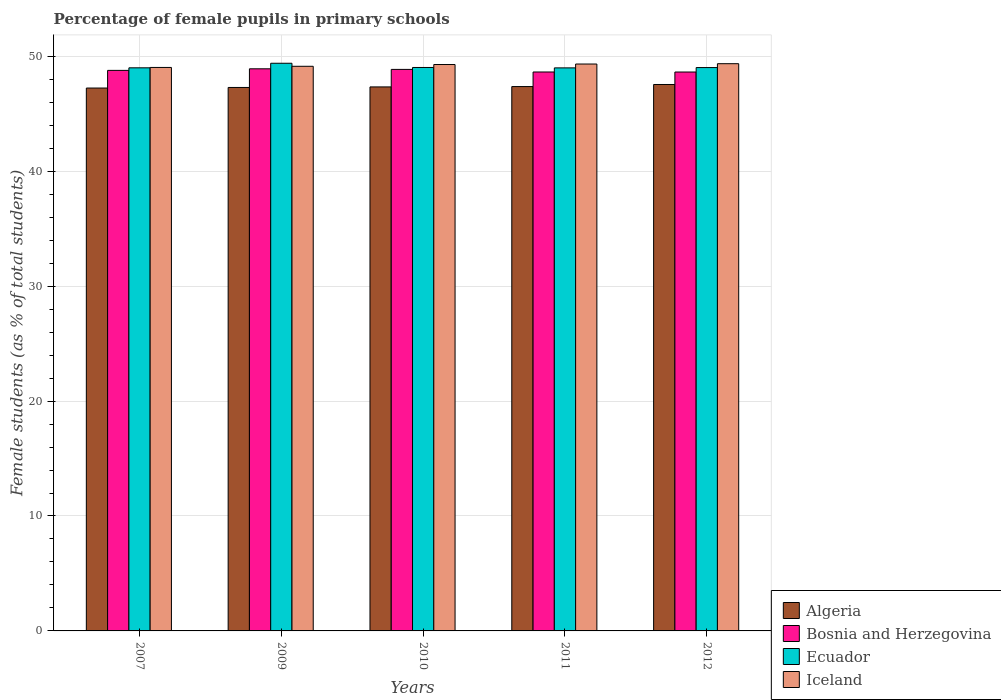How many groups of bars are there?
Ensure brevity in your answer.  5. Are the number of bars per tick equal to the number of legend labels?
Your answer should be compact. Yes. What is the percentage of female pupils in primary schools in Algeria in 2010?
Your response must be concise. 47.34. Across all years, what is the maximum percentage of female pupils in primary schools in Bosnia and Herzegovina?
Your response must be concise. 48.91. Across all years, what is the minimum percentage of female pupils in primary schools in Ecuador?
Offer a terse response. 48.99. What is the total percentage of female pupils in primary schools in Ecuador in the graph?
Provide a short and direct response. 245.42. What is the difference between the percentage of female pupils in primary schools in Iceland in 2007 and that in 2012?
Your response must be concise. -0.33. What is the difference between the percentage of female pupils in primary schools in Ecuador in 2010 and the percentage of female pupils in primary schools in Algeria in 2009?
Provide a succinct answer. 1.74. What is the average percentage of female pupils in primary schools in Ecuador per year?
Offer a very short reply. 49.08. In the year 2010, what is the difference between the percentage of female pupils in primary schools in Iceland and percentage of female pupils in primary schools in Bosnia and Herzegovina?
Provide a short and direct response. 0.42. What is the ratio of the percentage of female pupils in primary schools in Ecuador in 2009 to that in 2012?
Your response must be concise. 1.01. What is the difference between the highest and the second highest percentage of female pupils in primary schools in Ecuador?
Give a very brief answer. 0.37. What is the difference between the highest and the lowest percentage of female pupils in primary schools in Iceland?
Make the answer very short. 0.33. In how many years, is the percentage of female pupils in primary schools in Ecuador greater than the average percentage of female pupils in primary schools in Ecuador taken over all years?
Offer a very short reply. 1. Is it the case that in every year, the sum of the percentage of female pupils in primary schools in Algeria and percentage of female pupils in primary schools in Iceland is greater than the sum of percentage of female pupils in primary schools in Ecuador and percentage of female pupils in primary schools in Bosnia and Herzegovina?
Offer a very short reply. No. What does the 3rd bar from the left in 2007 represents?
Your answer should be compact. Ecuador. What does the 4th bar from the right in 2010 represents?
Ensure brevity in your answer.  Algeria. Is it the case that in every year, the sum of the percentage of female pupils in primary schools in Iceland and percentage of female pupils in primary schools in Ecuador is greater than the percentage of female pupils in primary schools in Bosnia and Herzegovina?
Make the answer very short. Yes. Are all the bars in the graph horizontal?
Your response must be concise. No. How many years are there in the graph?
Make the answer very short. 5. What is the difference between two consecutive major ticks on the Y-axis?
Your answer should be compact. 10. Does the graph contain any zero values?
Your response must be concise. No. Does the graph contain grids?
Provide a succinct answer. Yes. Where does the legend appear in the graph?
Your answer should be compact. Bottom right. How many legend labels are there?
Ensure brevity in your answer.  4. How are the legend labels stacked?
Offer a very short reply. Vertical. What is the title of the graph?
Your answer should be very brief. Percentage of female pupils in primary schools. Does "United Arab Emirates" appear as one of the legend labels in the graph?
Your response must be concise. No. What is the label or title of the X-axis?
Provide a short and direct response. Years. What is the label or title of the Y-axis?
Your answer should be compact. Female students (as % of total students). What is the Female students (as % of total students) in Algeria in 2007?
Offer a very short reply. 47.24. What is the Female students (as % of total students) in Bosnia and Herzegovina in 2007?
Provide a succinct answer. 48.77. What is the Female students (as % of total students) in Ecuador in 2007?
Provide a succinct answer. 49. What is the Female students (as % of total students) of Iceland in 2007?
Offer a very short reply. 49.03. What is the Female students (as % of total students) of Algeria in 2009?
Offer a very short reply. 47.29. What is the Female students (as % of total students) of Bosnia and Herzegovina in 2009?
Provide a short and direct response. 48.91. What is the Female students (as % of total students) of Ecuador in 2009?
Make the answer very short. 49.39. What is the Female students (as % of total students) in Iceland in 2009?
Provide a succinct answer. 49.13. What is the Female students (as % of total students) of Algeria in 2010?
Keep it short and to the point. 47.34. What is the Female students (as % of total students) in Bosnia and Herzegovina in 2010?
Your answer should be very brief. 48.86. What is the Female students (as % of total students) of Ecuador in 2010?
Keep it short and to the point. 49.03. What is the Female students (as % of total students) of Iceland in 2010?
Your answer should be compact. 49.28. What is the Female students (as % of total students) in Algeria in 2011?
Your response must be concise. 47.37. What is the Female students (as % of total students) of Bosnia and Herzegovina in 2011?
Offer a very short reply. 48.63. What is the Female students (as % of total students) of Ecuador in 2011?
Provide a short and direct response. 48.99. What is the Female students (as % of total students) of Iceland in 2011?
Your response must be concise. 49.33. What is the Female students (as % of total students) in Algeria in 2012?
Your answer should be very brief. 47.54. What is the Female students (as % of total students) of Bosnia and Herzegovina in 2012?
Give a very brief answer. 48.63. What is the Female students (as % of total students) of Ecuador in 2012?
Offer a very short reply. 49.02. What is the Female students (as % of total students) of Iceland in 2012?
Offer a very short reply. 49.36. Across all years, what is the maximum Female students (as % of total students) in Algeria?
Ensure brevity in your answer.  47.54. Across all years, what is the maximum Female students (as % of total students) in Bosnia and Herzegovina?
Ensure brevity in your answer.  48.91. Across all years, what is the maximum Female students (as % of total students) of Ecuador?
Make the answer very short. 49.39. Across all years, what is the maximum Female students (as % of total students) of Iceland?
Your answer should be very brief. 49.36. Across all years, what is the minimum Female students (as % of total students) of Algeria?
Ensure brevity in your answer.  47.24. Across all years, what is the minimum Female students (as % of total students) of Bosnia and Herzegovina?
Offer a terse response. 48.63. Across all years, what is the minimum Female students (as % of total students) of Ecuador?
Offer a terse response. 48.99. Across all years, what is the minimum Female students (as % of total students) in Iceland?
Make the answer very short. 49.03. What is the total Female students (as % of total students) in Algeria in the graph?
Provide a succinct answer. 236.77. What is the total Female students (as % of total students) of Bosnia and Herzegovina in the graph?
Your response must be concise. 243.81. What is the total Female students (as % of total students) of Ecuador in the graph?
Offer a terse response. 245.42. What is the total Female students (as % of total students) of Iceland in the graph?
Your answer should be very brief. 246.12. What is the difference between the Female students (as % of total students) of Algeria in 2007 and that in 2009?
Give a very brief answer. -0.05. What is the difference between the Female students (as % of total students) in Bosnia and Herzegovina in 2007 and that in 2009?
Provide a succinct answer. -0.14. What is the difference between the Female students (as % of total students) in Ecuador in 2007 and that in 2009?
Your answer should be very brief. -0.4. What is the difference between the Female students (as % of total students) of Iceland in 2007 and that in 2009?
Keep it short and to the point. -0.1. What is the difference between the Female students (as % of total students) in Algeria in 2007 and that in 2010?
Your answer should be very brief. -0.1. What is the difference between the Female students (as % of total students) of Bosnia and Herzegovina in 2007 and that in 2010?
Offer a very short reply. -0.09. What is the difference between the Female students (as % of total students) in Ecuador in 2007 and that in 2010?
Provide a short and direct response. -0.03. What is the difference between the Female students (as % of total students) of Iceland in 2007 and that in 2010?
Ensure brevity in your answer.  -0.25. What is the difference between the Female students (as % of total students) of Algeria in 2007 and that in 2011?
Your answer should be very brief. -0.13. What is the difference between the Female students (as % of total students) of Bosnia and Herzegovina in 2007 and that in 2011?
Offer a very short reply. 0.14. What is the difference between the Female students (as % of total students) of Ecuador in 2007 and that in 2011?
Give a very brief answer. 0.01. What is the difference between the Female students (as % of total students) of Iceland in 2007 and that in 2011?
Your response must be concise. -0.3. What is the difference between the Female students (as % of total students) in Algeria in 2007 and that in 2012?
Your response must be concise. -0.31. What is the difference between the Female students (as % of total students) of Bosnia and Herzegovina in 2007 and that in 2012?
Offer a terse response. 0.14. What is the difference between the Female students (as % of total students) in Ecuador in 2007 and that in 2012?
Offer a very short reply. -0.02. What is the difference between the Female students (as % of total students) of Iceland in 2007 and that in 2012?
Give a very brief answer. -0.33. What is the difference between the Female students (as % of total students) of Algeria in 2009 and that in 2010?
Give a very brief answer. -0.05. What is the difference between the Female students (as % of total students) of Bosnia and Herzegovina in 2009 and that in 2010?
Your response must be concise. 0.05. What is the difference between the Female students (as % of total students) in Ecuador in 2009 and that in 2010?
Keep it short and to the point. 0.37. What is the difference between the Female students (as % of total students) of Iceland in 2009 and that in 2010?
Your answer should be very brief. -0.15. What is the difference between the Female students (as % of total students) of Algeria in 2009 and that in 2011?
Ensure brevity in your answer.  -0.08. What is the difference between the Female students (as % of total students) of Bosnia and Herzegovina in 2009 and that in 2011?
Your answer should be very brief. 0.28. What is the difference between the Female students (as % of total students) of Ecuador in 2009 and that in 2011?
Your answer should be compact. 0.4. What is the difference between the Female students (as % of total students) in Iceland in 2009 and that in 2011?
Provide a short and direct response. -0.2. What is the difference between the Female students (as % of total students) of Algeria in 2009 and that in 2012?
Offer a terse response. -0.26. What is the difference between the Female students (as % of total students) in Bosnia and Herzegovina in 2009 and that in 2012?
Ensure brevity in your answer.  0.28. What is the difference between the Female students (as % of total students) of Ecuador in 2009 and that in 2012?
Your response must be concise. 0.38. What is the difference between the Female students (as % of total students) in Iceland in 2009 and that in 2012?
Your response must be concise. -0.23. What is the difference between the Female students (as % of total students) in Algeria in 2010 and that in 2011?
Keep it short and to the point. -0.03. What is the difference between the Female students (as % of total students) in Bosnia and Herzegovina in 2010 and that in 2011?
Your answer should be compact. 0.23. What is the difference between the Female students (as % of total students) in Ecuador in 2010 and that in 2011?
Offer a terse response. 0.03. What is the difference between the Female students (as % of total students) in Iceland in 2010 and that in 2011?
Give a very brief answer. -0.04. What is the difference between the Female students (as % of total students) in Algeria in 2010 and that in 2012?
Keep it short and to the point. -0.21. What is the difference between the Female students (as % of total students) of Bosnia and Herzegovina in 2010 and that in 2012?
Ensure brevity in your answer.  0.23. What is the difference between the Female students (as % of total students) in Ecuador in 2010 and that in 2012?
Offer a very short reply. 0.01. What is the difference between the Female students (as % of total students) of Iceland in 2010 and that in 2012?
Ensure brevity in your answer.  -0.07. What is the difference between the Female students (as % of total students) in Algeria in 2011 and that in 2012?
Your answer should be very brief. -0.18. What is the difference between the Female students (as % of total students) of Bosnia and Herzegovina in 2011 and that in 2012?
Keep it short and to the point. 0. What is the difference between the Female students (as % of total students) of Ecuador in 2011 and that in 2012?
Provide a succinct answer. -0.03. What is the difference between the Female students (as % of total students) of Iceland in 2011 and that in 2012?
Your answer should be compact. -0.03. What is the difference between the Female students (as % of total students) of Algeria in 2007 and the Female students (as % of total students) of Bosnia and Herzegovina in 2009?
Your answer should be very brief. -1.67. What is the difference between the Female students (as % of total students) in Algeria in 2007 and the Female students (as % of total students) in Ecuador in 2009?
Make the answer very short. -2.16. What is the difference between the Female students (as % of total students) in Algeria in 2007 and the Female students (as % of total students) in Iceland in 2009?
Your answer should be compact. -1.89. What is the difference between the Female students (as % of total students) of Bosnia and Herzegovina in 2007 and the Female students (as % of total students) of Ecuador in 2009?
Ensure brevity in your answer.  -0.62. What is the difference between the Female students (as % of total students) of Bosnia and Herzegovina in 2007 and the Female students (as % of total students) of Iceland in 2009?
Provide a succinct answer. -0.36. What is the difference between the Female students (as % of total students) in Ecuador in 2007 and the Female students (as % of total students) in Iceland in 2009?
Give a very brief answer. -0.13. What is the difference between the Female students (as % of total students) of Algeria in 2007 and the Female students (as % of total students) of Bosnia and Herzegovina in 2010?
Your answer should be compact. -1.62. What is the difference between the Female students (as % of total students) in Algeria in 2007 and the Female students (as % of total students) in Ecuador in 2010?
Ensure brevity in your answer.  -1.79. What is the difference between the Female students (as % of total students) of Algeria in 2007 and the Female students (as % of total students) of Iceland in 2010?
Offer a terse response. -2.05. What is the difference between the Female students (as % of total students) in Bosnia and Herzegovina in 2007 and the Female students (as % of total students) in Ecuador in 2010?
Your answer should be compact. -0.25. What is the difference between the Female students (as % of total students) of Bosnia and Herzegovina in 2007 and the Female students (as % of total students) of Iceland in 2010?
Your answer should be compact. -0.51. What is the difference between the Female students (as % of total students) of Ecuador in 2007 and the Female students (as % of total students) of Iceland in 2010?
Offer a terse response. -0.29. What is the difference between the Female students (as % of total students) in Algeria in 2007 and the Female students (as % of total students) in Bosnia and Herzegovina in 2011?
Give a very brief answer. -1.4. What is the difference between the Female students (as % of total students) in Algeria in 2007 and the Female students (as % of total students) in Ecuador in 2011?
Offer a very short reply. -1.75. What is the difference between the Female students (as % of total students) of Algeria in 2007 and the Female students (as % of total students) of Iceland in 2011?
Your response must be concise. -2.09. What is the difference between the Female students (as % of total students) in Bosnia and Herzegovina in 2007 and the Female students (as % of total students) in Ecuador in 2011?
Offer a very short reply. -0.22. What is the difference between the Female students (as % of total students) of Bosnia and Herzegovina in 2007 and the Female students (as % of total students) of Iceland in 2011?
Keep it short and to the point. -0.55. What is the difference between the Female students (as % of total students) of Ecuador in 2007 and the Female students (as % of total students) of Iceland in 2011?
Your answer should be compact. -0.33. What is the difference between the Female students (as % of total students) in Algeria in 2007 and the Female students (as % of total students) in Bosnia and Herzegovina in 2012?
Ensure brevity in your answer.  -1.39. What is the difference between the Female students (as % of total students) of Algeria in 2007 and the Female students (as % of total students) of Ecuador in 2012?
Your answer should be very brief. -1.78. What is the difference between the Female students (as % of total students) in Algeria in 2007 and the Female students (as % of total students) in Iceland in 2012?
Give a very brief answer. -2.12. What is the difference between the Female students (as % of total students) in Bosnia and Herzegovina in 2007 and the Female students (as % of total students) in Ecuador in 2012?
Your answer should be very brief. -0.24. What is the difference between the Female students (as % of total students) of Bosnia and Herzegovina in 2007 and the Female students (as % of total students) of Iceland in 2012?
Keep it short and to the point. -0.58. What is the difference between the Female students (as % of total students) of Ecuador in 2007 and the Female students (as % of total students) of Iceland in 2012?
Make the answer very short. -0.36. What is the difference between the Female students (as % of total students) in Algeria in 2009 and the Female students (as % of total students) in Bosnia and Herzegovina in 2010?
Offer a very short reply. -1.57. What is the difference between the Female students (as % of total students) of Algeria in 2009 and the Female students (as % of total students) of Ecuador in 2010?
Your response must be concise. -1.74. What is the difference between the Female students (as % of total students) in Algeria in 2009 and the Female students (as % of total students) in Iceland in 2010?
Provide a short and direct response. -2. What is the difference between the Female students (as % of total students) of Bosnia and Herzegovina in 2009 and the Female students (as % of total students) of Ecuador in 2010?
Make the answer very short. -0.11. What is the difference between the Female students (as % of total students) in Bosnia and Herzegovina in 2009 and the Female students (as % of total students) in Iceland in 2010?
Make the answer very short. -0.37. What is the difference between the Female students (as % of total students) in Ecuador in 2009 and the Female students (as % of total students) in Iceland in 2010?
Offer a very short reply. 0.11. What is the difference between the Female students (as % of total students) in Algeria in 2009 and the Female students (as % of total students) in Bosnia and Herzegovina in 2011?
Provide a short and direct response. -1.35. What is the difference between the Female students (as % of total students) in Algeria in 2009 and the Female students (as % of total students) in Ecuador in 2011?
Your response must be concise. -1.7. What is the difference between the Female students (as % of total students) in Algeria in 2009 and the Female students (as % of total students) in Iceland in 2011?
Offer a very short reply. -2.04. What is the difference between the Female students (as % of total students) in Bosnia and Herzegovina in 2009 and the Female students (as % of total students) in Ecuador in 2011?
Provide a short and direct response. -0.08. What is the difference between the Female students (as % of total students) in Bosnia and Herzegovina in 2009 and the Female students (as % of total students) in Iceland in 2011?
Keep it short and to the point. -0.42. What is the difference between the Female students (as % of total students) of Ecuador in 2009 and the Female students (as % of total students) of Iceland in 2011?
Offer a very short reply. 0.07. What is the difference between the Female students (as % of total students) of Algeria in 2009 and the Female students (as % of total students) of Bosnia and Herzegovina in 2012?
Your answer should be compact. -1.34. What is the difference between the Female students (as % of total students) of Algeria in 2009 and the Female students (as % of total students) of Ecuador in 2012?
Give a very brief answer. -1.73. What is the difference between the Female students (as % of total students) in Algeria in 2009 and the Female students (as % of total students) in Iceland in 2012?
Offer a terse response. -2.07. What is the difference between the Female students (as % of total students) in Bosnia and Herzegovina in 2009 and the Female students (as % of total students) in Ecuador in 2012?
Your response must be concise. -0.11. What is the difference between the Female students (as % of total students) of Bosnia and Herzegovina in 2009 and the Female students (as % of total students) of Iceland in 2012?
Keep it short and to the point. -0.44. What is the difference between the Female students (as % of total students) in Ecuador in 2009 and the Female students (as % of total students) in Iceland in 2012?
Give a very brief answer. 0.04. What is the difference between the Female students (as % of total students) in Algeria in 2010 and the Female students (as % of total students) in Bosnia and Herzegovina in 2011?
Offer a terse response. -1.3. What is the difference between the Female students (as % of total students) of Algeria in 2010 and the Female students (as % of total students) of Ecuador in 2011?
Give a very brief answer. -1.66. What is the difference between the Female students (as % of total students) in Algeria in 2010 and the Female students (as % of total students) in Iceland in 2011?
Keep it short and to the point. -1.99. What is the difference between the Female students (as % of total students) of Bosnia and Herzegovina in 2010 and the Female students (as % of total students) of Ecuador in 2011?
Provide a short and direct response. -0.13. What is the difference between the Female students (as % of total students) of Bosnia and Herzegovina in 2010 and the Female students (as % of total students) of Iceland in 2011?
Keep it short and to the point. -0.47. What is the difference between the Female students (as % of total students) of Ecuador in 2010 and the Female students (as % of total students) of Iceland in 2011?
Ensure brevity in your answer.  -0.3. What is the difference between the Female students (as % of total students) of Algeria in 2010 and the Female students (as % of total students) of Bosnia and Herzegovina in 2012?
Your answer should be compact. -1.3. What is the difference between the Female students (as % of total students) in Algeria in 2010 and the Female students (as % of total students) in Ecuador in 2012?
Your answer should be compact. -1.68. What is the difference between the Female students (as % of total students) of Algeria in 2010 and the Female students (as % of total students) of Iceland in 2012?
Give a very brief answer. -2.02. What is the difference between the Female students (as % of total students) in Bosnia and Herzegovina in 2010 and the Female students (as % of total students) in Ecuador in 2012?
Your response must be concise. -0.16. What is the difference between the Female students (as % of total students) in Bosnia and Herzegovina in 2010 and the Female students (as % of total students) in Iceland in 2012?
Provide a succinct answer. -0.5. What is the difference between the Female students (as % of total students) in Ecuador in 2010 and the Female students (as % of total students) in Iceland in 2012?
Make the answer very short. -0.33. What is the difference between the Female students (as % of total students) of Algeria in 2011 and the Female students (as % of total students) of Bosnia and Herzegovina in 2012?
Offer a very short reply. -1.27. What is the difference between the Female students (as % of total students) in Algeria in 2011 and the Female students (as % of total students) in Ecuador in 2012?
Ensure brevity in your answer.  -1.65. What is the difference between the Female students (as % of total students) in Algeria in 2011 and the Female students (as % of total students) in Iceland in 2012?
Your answer should be very brief. -1.99. What is the difference between the Female students (as % of total students) in Bosnia and Herzegovina in 2011 and the Female students (as % of total students) in Ecuador in 2012?
Your response must be concise. -0.38. What is the difference between the Female students (as % of total students) in Bosnia and Herzegovina in 2011 and the Female students (as % of total students) in Iceland in 2012?
Provide a succinct answer. -0.72. What is the difference between the Female students (as % of total students) of Ecuador in 2011 and the Female students (as % of total students) of Iceland in 2012?
Your answer should be very brief. -0.36. What is the average Female students (as % of total students) in Algeria per year?
Your response must be concise. 47.35. What is the average Female students (as % of total students) in Bosnia and Herzegovina per year?
Your response must be concise. 48.76. What is the average Female students (as % of total students) in Ecuador per year?
Offer a very short reply. 49.09. What is the average Female students (as % of total students) in Iceland per year?
Ensure brevity in your answer.  49.22. In the year 2007, what is the difference between the Female students (as % of total students) in Algeria and Female students (as % of total students) in Bosnia and Herzegovina?
Offer a very short reply. -1.54. In the year 2007, what is the difference between the Female students (as % of total students) of Algeria and Female students (as % of total students) of Ecuador?
Keep it short and to the point. -1.76. In the year 2007, what is the difference between the Female students (as % of total students) of Algeria and Female students (as % of total students) of Iceland?
Ensure brevity in your answer.  -1.79. In the year 2007, what is the difference between the Female students (as % of total students) in Bosnia and Herzegovina and Female students (as % of total students) in Ecuador?
Your answer should be very brief. -0.22. In the year 2007, what is the difference between the Female students (as % of total students) of Bosnia and Herzegovina and Female students (as % of total students) of Iceland?
Give a very brief answer. -0.26. In the year 2007, what is the difference between the Female students (as % of total students) of Ecuador and Female students (as % of total students) of Iceland?
Provide a succinct answer. -0.03. In the year 2009, what is the difference between the Female students (as % of total students) in Algeria and Female students (as % of total students) in Bosnia and Herzegovina?
Your response must be concise. -1.62. In the year 2009, what is the difference between the Female students (as % of total students) of Algeria and Female students (as % of total students) of Ecuador?
Make the answer very short. -2.11. In the year 2009, what is the difference between the Female students (as % of total students) in Algeria and Female students (as % of total students) in Iceland?
Provide a succinct answer. -1.84. In the year 2009, what is the difference between the Female students (as % of total students) in Bosnia and Herzegovina and Female students (as % of total students) in Ecuador?
Keep it short and to the point. -0.48. In the year 2009, what is the difference between the Female students (as % of total students) in Bosnia and Herzegovina and Female students (as % of total students) in Iceland?
Your answer should be compact. -0.22. In the year 2009, what is the difference between the Female students (as % of total students) of Ecuador and Female students (as % of total students) of Iceland?
Offer a very short reply. 0.26. In the year 2010, what is the difference between the Female students (as % of total students) in Algeria and Female students (as % of total students) in Bosnia and Herzegovina?
Offer a very short reply. -1.52. In the year 2010, what is the difference between the Female students (as % of total students) of Algeria and Female students (as % of total students) of Ecuador?
Your answer should be very brief. -1.69. In the year 2010, what is the difference between the Female students (as % of total students) in Algeria and Female students (as % of total students) in Iceland?
Give a very brief answer. -1.95. In the year 2010, what is the difference between the Female students (as % of total students) in Bosnia and Herzegovina and Female students (as % of total students) in Ecuador?
Provide a succinct answer. -0.17. In the year 2010, what is the difference between the Female students (as % of total students) in Bosnia and Herzegovina and Female students (as % of total students) in Iceland?
Ensure brevity in your answer.  -0.42. In the year 2010, what is the difference between the Female students (as % of total students) in Ecuador and Female students (as % of total students) in Iceland?
Keep it short and to the point. -0.26. In the year 2011, what is the difference between the Female students (as % of total students) in Algeria and Female students (as % of total students) in Bosnia and Herzegovina?
Make the answer very short. -1.27. In the year 2011, what is the difference between the Female students (as % of total students) of Algeria and Female students (as % of total students) of Ecuador?
Your response must be concise. -1.63. In the year 2011, what is the difference between the Female students (as % of total students) in Algeria and Female students (as % of total students) in Iceland?
Offer a terse response. -1.96. In the year 2011, what is the difference between the Female students (as % of total students) in Bosnia and Herzegovina and Female students (as % of total students) in Ecuador?
Provide a short and direct response. -0.36. In the year 2011, what is the difference between the Female students (as % of total students) of Bosnia and Herzegovina and Female students (as % of total students) of Iceland?
Keep it short and to the point. -0.69. In the year 2011, what is the difference between the Female students (as % of total students) of Ecuador and Female students (as % of total students) of Iceland?
Offer a very short reply. -0.34. In the year 2012, what is the difference between the Female students (as % of total students) in Algeria and Female students (as % of total students) in Bosnia and Herzegovina?
Make the answer very short. -1.09. In the year 2012, what is the difference between the Female students (as % of total students) of Algeria and Female students (as % of total students) of Ecuador?
Offer a very short reply. -1.47. In the year 2012, what is the difference between the Female students (as % of total students) in Algeria and Female students (as % of total students) in Iceland?
Give a very brief answer. -1.81. In the year 2012, what is the difference between the Female students (as % of total students) in Bosnia and Herzegovina and Female students (as % of total students) in Ecuador?
Provide a short and direct response. -0.39. In the year 2012, what is the difference between the Female students (as % of total students) in Bosnia and Herzegovina and Female students (as % of total students) in Iceland?
Offer a very short reply. -0.72. In the year 2012, what is the difference between the Female students (as % of total students) in Ecuador and Female students (as % of total students) in Iceland?
Offer a terse response. -0.34. What is the ratio of the Female students (as % of total students) in Algeria in 2007 to that in 2009?
Offer a very short reply. 1. What is the ratio of the Female students (as % of total students) of Iceland in 2007 to that in 2009?
Provide a succinct answer. 1. What is the ratio of the Female students (as % of total students) in Algeria in 2007 to that in 2010?
Your response must be concise. 1. What is the ratio of the Female students (as % of total students) in Bosnia and Herzegovina in 2007 to that in 2010?
Your answer should be compact. 1. What is the ratio of the Female students (as % of total students) of Iceland in 2007 to that in 2010?
Your answer should be very brief. 0.99. What is the ratio of the Female students (as % of total students) in Algeria in 2007 to that in 2011?
Your answer should be compact. 1. What is the ratio of the Female students (as % of total students) of Bosnia and Herzegovina in 2007 to that in 2011?
Your answer should be very brief. 1. What is the ratio of the Female students (as % of total students) in Ecuador in 2007 to that in 2011?
Provide a succinct answer. 1. What is the ratio of the Female students (as % of total students) of Bosnia and Herzegovina in 2007 to that in 2012?
Your answer should be compact. 1. What is the ratio of the Female students (as % of total students) in Ecuador in 2007 to that in 2012?
Keep it short and to the point. 1. What is the ratio of the Female students (as % of total students) of Iceland in 2007 to that in 2012?
Your response must be concise. 0.99. What is the ratio of the Female students (as % of total students) in Algeria in 2009 to that in 2010?
Provide a short and direct response. 1. What is the ratio of the Female students (as % of total students) of Ecuador in 2009 to that in 2010?
Ensure brevity in your answer.  1.01. What is the ratio of the Female students (as % of total students) of Iceland in 2009 to that in 2010?
Give a very brief answer. 1. What is the ratio of the Female students (as % of total students) in Ecuador in 2009 to that in 2011?
Ensure brevity in your answer.  1.01. What is the ratio of the Female students (as % of total students) in Bosnia and Herzegovina in 2009 to that in 2012?
Keep it short and to the point. 1.01. What is the ratio of the Female students (as % of total students) in Ecuador in 2009 to that in 2012?
Make the answer very short. 1.01. What is the ratio of the Female students (as % of total students) in Iceland in 2009 to that in 2012?
Your answer should be very brief. 1. What is the ratio of the Female students (as % of total students) of Algeria in 2010 to that in 2011?
Ensure brevity in your answer.  1. What is the ratio of the Female students (as % of total students) in Bosnia and Herzegovina in 2010 to that in 2011?
Your answer should be very brief. 1. What is the ratio of the Female students (as % of total students) of Bosnia and Herzegovina in 2010 to that in 2012?
Ensure brevity in your answer.  1. What is the ratio of the Female students (as % of total students) of Iceland in 2010 to that in 2012?
Make the answer very short. 1. What is the ratio of the Female students (as % of total students) of Algeria in 2011 to that in 2012?
Keep it short and to the point. 1. What is the ratio of the Female students (as % of total students) of Ecuador in 2011 to that in 2012?
Make the answer very short. 1. What is the ratio of the Female students (as % of total students) of Iceland in 2011 to that in 2012?
Offer a very short reply. 1. What is the difference between the highest and the second highest Female students (as % of total students) in Algeria?
Offer a very short reply. 0.18. What is the difference between the highest and the second highest Female students (as % of total students) of Bosnia and Herzegovina?
Ensure brevity in your answer.  0.05. What is the difference between the highest and the second highest Female students (as % of total students) in Ecuador?
Keep it short and to the point. 0.37. What is the difference between the highest and the second highest Female students (as % of total students) of Iceland?
Ensure brevity in your answer.  0.03. What is the difference between the highest and the lowest Female students (as % of total students) of Algeria?
Your response must be concise. 0.31. What is the difference between the highest and the lowest Female students (as % of total students) in Bosnia and Herzegovina?
Your answer should be compact. 0.28. What is the difference between the highest and the lowest Female students (as % of total students) in Ecuador?
Offer a terse response. 0.4. What is the difference between the highest and the lowest Female students (as % of total students) of Iceland?
Offer a very short reply. 0.33. 